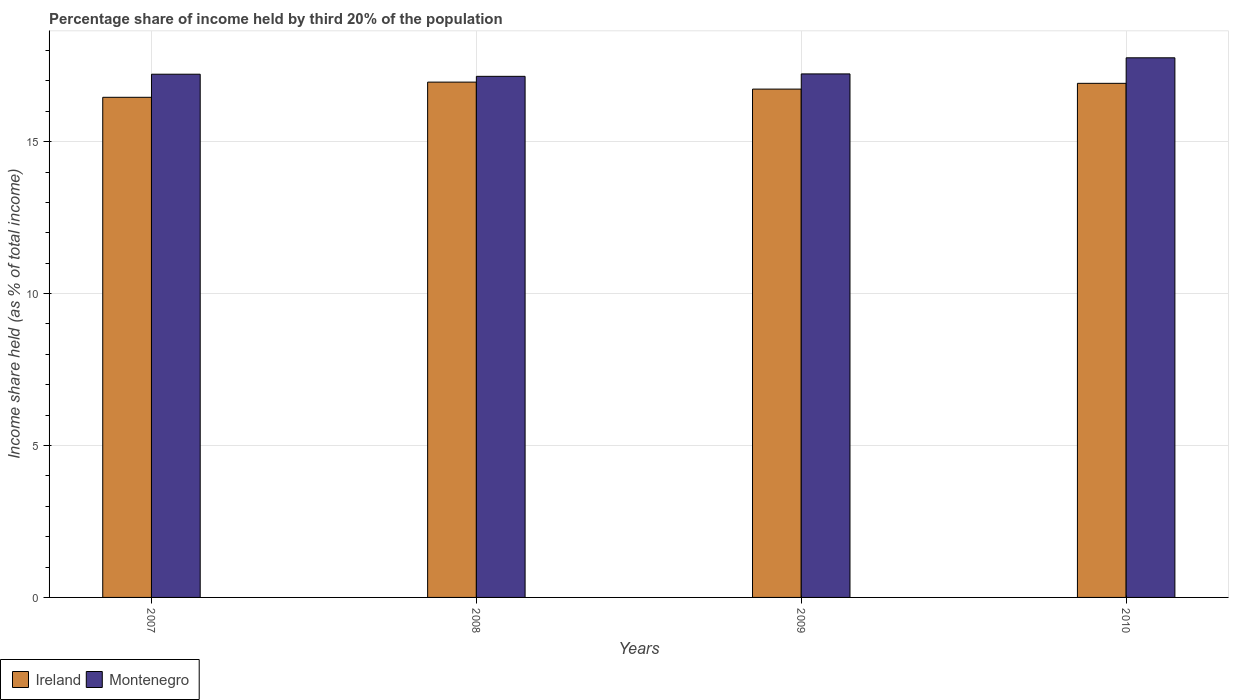How many different coloured bars are there?
Your response must be concise. 2. How many groups of bars are there?
Provide a succinct answer. 4. Are the number of bars on each tick of the X-axis equal?
Ensure brevity in your answer.  Yes. In how many cases, is the number of bars for a given year not equal to the number of legend labels?
Your answer should be very brief. 0. What is the share of income held by third 20% of the population in Montenegro in 2007?
Ensure brevity in your answer.  17.22. Across all years, what is the maximum share of income held by third 20% of the population in Ireland?
Make the answer very short. 16.96. Across all years, what is the minimum share of income held by third 20% of the population in Montenegro?
Give a very brief answer. 17.15. In which year was the share of income held by third 20% of the population in Montenegro minimum?
Make the answer very short. 2008. What is the total share of income held by third 20% of the population in Ireland in the graph?
Your response must be concise. 67.07. What is the difference between the share of income held by third 20% of the population in Montenegro in 2007 and that in 2008?
Your response must be concise. 0.07. What is the difference between the share of income held by third 20% of the population in Ireland in 2007 and the share of income held by third 20% of the population in Montenegro in 2009?
Keep it short and to the point. -0.77. What is the average share of income held by third 20% of the population in Montenegro per year?
Keep it short and to the point. 17.34. In the year 2007, what is the difference between the share of income held by third 20% of the population in Ireland and share of income held by third 20% of the population in Montenegro?
Make the answer very short. -0.76. What is the ratio of the share of income held by third 20% of the population in Montenegro in 2008 to that in 2009?
Give a very brief answer. 1. Is the share of income held by third 20% of the population in Montenegro in 2009 less than that in 2010?
Offer a very short reply. Yes. Is the difference between the share of income held by third 20% of the population in Ireland in 2007 and 2008 greater than the difference between the share of income held by third 20% of the population in Montenegro in 2007 and 2008?
Offer a terse response. No. What is the difference between the highest and the second highest share of income held by third 20% of the population in Montenegro?
Your answer should be very brief. 0.53. What is the difference between the highest and the lowest share of income held by third 20% of the population in Montenegro?
Provide a succinct answer. 0.61. What does the 2nd bar from the left in 2008 represents?
Offer a terse response. Montenegro. What does the 2nd bar from the right in 2010 represents?
Your response must be concise. Ireland. Are all the bars in the graph horizontal?
Offer a terse response. No. How many years are there in the graph?
Keep it short and to the point. 4. What is the difference between two consecutive major ticks on the Y-axis?
Make the answer very short. 5. Are the values on the major ticks of Y-axis written in scientific E-notation?
Your answer should be very brief. No. Does the graph contain grids?
Offer a very short reply. Yes. How many legend labels are there?
Ensure brevity in your answer.  2. How are the legend labels stacked?
Give a very brief answer. Horizontal. What is the title of the graph?
Your response must be concise. Percentage share of income held by third 20% of the population. What is the label or title of the Y-axis?
Provide a succinct answer. Income share held (as % of total income). What is the Income share held (as % of total income) in Ireland in 2007?
Your response must be concise. 16.46. What is the Income share held (as % of total income) of Montenegro in 2007?
Provide a succinct answer. 17.22. What is the Income share held (as % of total income) of Ireland in 2008?
Your answer should be very brief. 16.96. What is the Income share held (as % of total income) in Montenegro in 2008?
Ensure brevity in your answer.  17.15. What is the Income share held (as % of total income) of Ireland in 2009?
Offer a terse response. 16.73. What is the Income share held (as % of total income) in Montenegro in 2009?
Provide a short and direct response. 17.23. What is the Income share held (as % of total income) of Ireland in 2010?
Make the answer very short. 16.92. What is the Income share held (as % of total income) in Montenegro in 2010?
Your answer should be compact. 17.76. Across all years, what is the maximum Income share held (as % of total income) in Ireland?
Offer a terse response. 16.96. Across all years, what is the maximum Income share held (as % of total income) of Montenegro?
Your response must be concise. 17.76. Across all years, what is the minimum Income share held (as % of total income) of Ireland?
Your answer should be very brief. 16.46. Across all years, what is the minimum Income share held (as % of total income) in Montenegro?
Ensure brevity in your answer.  17.15. What is the total Income share held (as % of total income) in Ireland in the graph?
Offer a terse response. 67.07. What is the total Income share held (as % of total income) of Montenegro in the graph?
Offer a very short reply. 69.36. What is the difference between the Income share held (as % of total income) in Montenegro in 2007 and that in 2008?
Your answer should be compact. 0.07. What is the difference between the Income share held (as % of total income) of Ireland in 2007 and that in 2009?
Keep it short and to the point. -0.27. What is the difference between the Income share held (as % of total income) in Montenegro in 2007 and that in 2009?
Your answer should be compact. -0.01. What is the difference between the Income share held (as % of total income) of Ireland in 2007 and that in 2010?
Offer a terse response. -0.46. What is the difference between the Income share held (as % of total income) in Montenegro in 2007 and that in 2010?
Give a very brief answer. -0.54. What is the difference between the Income share held (as % of total income) of Ireland in 2008 and that in 2009?
Ensure brevity in your answer.  0.23. What is the difference between the Income share held (as % of total income) of Montenegro in 2008 and that in 2009?
Your response must be concise. -0.08. What is the difference between the Income share held (as % of total income) in Ireland in 2008 and that in 2010?
Offer a very short reply. 0.04. What is the difference between the Income share held (as % of total income) in Montenegro in 2008 and that in 2010?
Ensure brevity in your answer.  -0.61. What is the difference between the Income share held (as % of total income) of Ireland in 2009 and that in 2010?
Provide a succinct answer. -0.19. What is the difference between the Income share held (as % of total income) in Montenegro in 2009 and that in 2010?
Give a very brief answer. -0.53. What is the difference between the Income share held (as % of total income) in Ireland in 2007 and the Income share held (as % of total income) in Montenegro in 2008?
Keep it short and to the point. -0.69. What is the difference between the Income share held (as % of total income) in Ireland in 2007 and the Income share held (as % of total income) in Montenegro in 2009?
Offer a very short reply. -0.77. What is the difference between the Income share held (as % of total income) of Ireland in 2007 and the Income share held (as % of total income) of Montenegro in 2010?
Make the answer very short. -1.3. What is the difference between the Income share held (as % of total income) of Ireland in 2008 and the Income share held (as % of total income) of Montenegro in 2009?
Keep it short and to the point. -0.27. What is the difference between the Income share held (as % of total income) in Ireland in 2008 and the Income share held (as % of total income) in Montenegro in 2010?
Provide a short and direct response. -0.8. What is the difference between the Income share held (as % of total income) in Ireland in 2009 and the Income share held (as % of total income) in Montenegro in 2010?
Ensure brevity in your answer.  -1.03. What is the average Income share held (as % of total income) of Ireland per year?
Give a very brief answer. 16.77. What is the average Income share held (as % of total income) of Montenegro per year?
Make the answer very short. 17.34. In the year 2007, what is the difference between the Income share held (as % of total income) in Ireland and Income share held (as % of total income) in Montenegro?
Make the answer very short. -0.76. In the year 2008, what is the difference between the Income share held (as % of total income) in Ireland and Income share held (as % of total income) in Montenegro?
Give a very brief answer. -0.19. In the year 2009, what is the difference between the Income share held (as % of total income) of Ireland and Income share held (as % of total income) of Montenegro?
Keep it short and to the point. -0.5. In the year 2010, what is the difference between the Income share held (as % of total income) in Ireland and Income share held (as % of total income) in Montenegro?
Provide a succinct answer. -0.84. What is the ratio of the Income share held (as % of total income) in Ireland in 2007 to that in 2008?
Offer a terse response. 0.97. What is the ratio of the Income share held (as % of total income) in Ireland in 2007 to that in 2009?
Provide a short and direct response. 0.98. What is the ratio of the Income share held (as % of total income) of Montenegro in 2007 to that in 2009?
Offer a very short reply. 1. What is the ratio of the Income share held (as % of total income) of Ireland in 2007 to that in 2010?
Provide a short and direct response. 0.97. What is the ratio of the Income share held (as % of total income) of Montenegro in 2007 to that in 2010?
Provide a succinct answer. 0.97. What is the ratio of the Income share held (as % of total income) of Ireland in 2008 to that in 2009?
Provide a short and direct response. 1.01. What is the ratio of the Income share held (as % of total income) of Montenegro in 2008 to that in 2010?
Make the answer very short. 0.97. What is the ratio of the Income share held (as % of total income) of Ireland in 2009 to that in 2010?
Make the answer very short. 0.99. What is the ratio of the Income share held (as % of total income) of Montenegro in 2009 to that in 2010?
Your answer should be compact. 0.97. What is the difference between the highest and the second highest Income share held (as % of total income) in Ireland?
Make the answer very short. 0.04. What is the difference between the highest and the second highest Income share held (as % of total income) of Montenegro?
Provide a short and direct response. 0.53. What is the difference between the highest and the lowest Income share held (as % of total income) in Montenegro?
Your answer should be very brief. 0.61. 